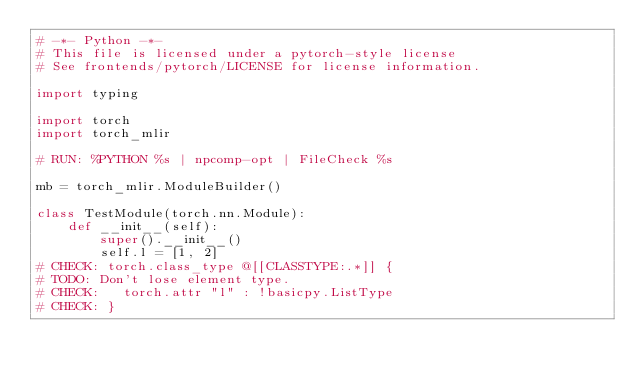Convert code to text. <code><loc_0><loc_0><loc_500><loc_500><_Python_># -*- Python -*-
# This file is licensed under a pytorch-style license
# See frontends/pytorch/LICENSE for license information.

import typing

import torch
import torch_mlir

# RUN: %PYTHON %s | npcomp-opt | FileCheck %s

mb = torch_mlir.ModuleBuilder()

class TestModule(torch.nn.Module):
    def __init__(self):
        super().__init__()
        self.l = [1, 2]
# CHECK: torch.class_type @[[CLASSTYPE:.*]] {
# TODO: Don't lose element type.
# CHECK:   torch.attr "l" : !basicpy.ListType
# CHECK: }</code> 